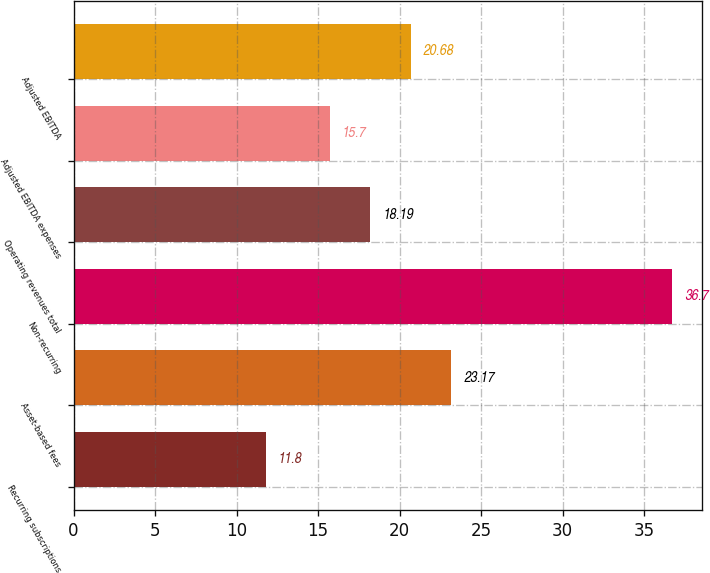Convert chart to OTSL. <chart><loc_0><loc_0><loc_500><loc_500><bar_chart><fcel>Recurring subscriptions<fcel>Asset-based fees<fcel>Non-recurring<fcel>Operating revenues total<fcel>Adjusted EBITDA expenses<fcel>Adjusted EBITDA<nl><fcel>11.8<fcel>23.17<fcel>36.7<fcel>18.19<fcel>15.7<fcel>20.68<nl></chart> 